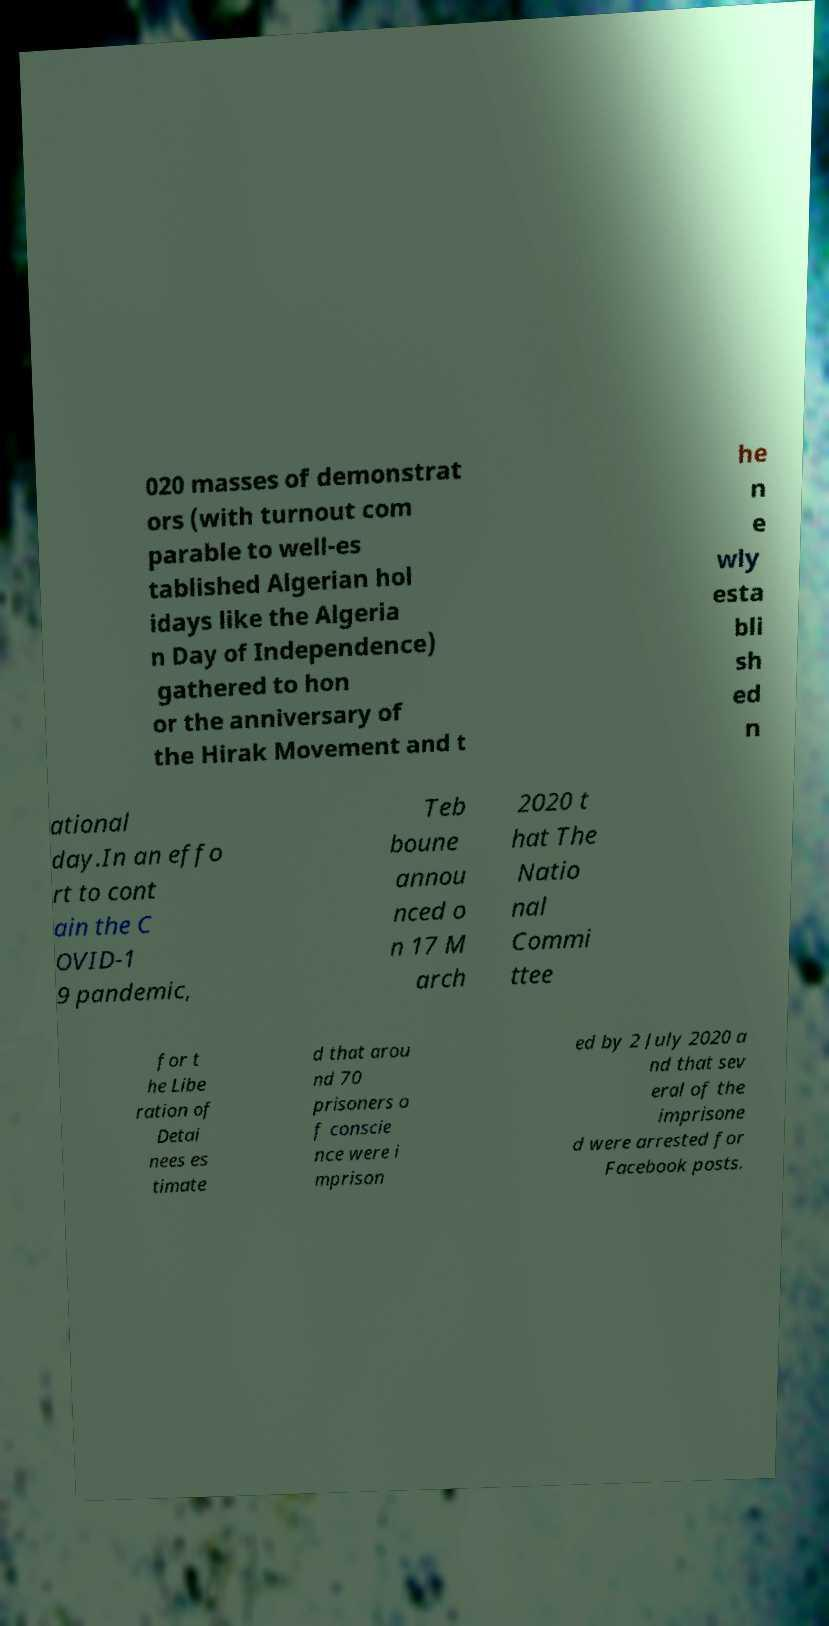Could you assist in decoding the text presented in this image and type it out clearly? 020 masses of demonstrat ors (with turnout com parable to well-es tablished Algerian hol idays like the Algeria n Day of Independence) gathered to hon or the anniversary of the Hirak Movement and t he n e wly esta bli sh ed n ational day.In an effo rt to cont ain the C OVID-1 9 pandemic, Teb boune annou nced o n 17 M arch 2020 t hat The Natio nal Commi ttee for t he Libe ration of Detai nees es timate d that arou nd 70 prisoners o f conscie nce were i mprison ed by 2 July 2020 a nd that sev eral of the imprisone d were arrested for Facebook posts. 